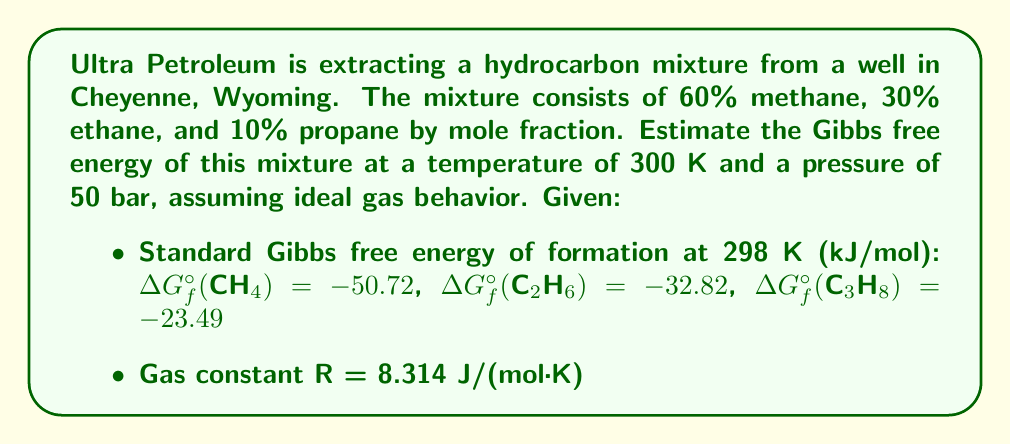Can you answer this question? To estimate the Gibbs free energy of the hydrocarbon mixture, we'll follow these steps:

1) First, calculate the standard Gibbs free energy of the mixture at 298 K:

   $$G_{mix}^{\circ} = \sum_{i} x_i \Delta G_f^{\circ}(i)$$

   where $x_i$ is the mole fraction of each component.

   $$G_{mix}^{\circ} = 0.6(-50.72) + 0.3(-32.82) + 0.1(-23.49) = -42.71 \text{ kJ/mol}$$

2) Adjust for temperature change from 298 K to 300 K. For small temperature changes, we can approximate:

   $$G(T) \approx G^{\circ} - S^{\circ}(T - 298)$$

   However, the change is so small (2 K) that we can neglect this adjustment.

3) Account for pressure change using the ideal gas equation:

   $$G(P) = G^{\circ} + RT \ln(\frac{P}{P^{\circ}})$$

   where $P^{\circ} = 1 \text{ bar}$

   $$G(50 \text{ bar}) = -42.71 \times 10^3 + 8.314 \times 300 \times \ln(50) = -34.71 \text{ kJ/mol}$$

4) Account for mixing entropy:

   $$G_{mixing} = RT \sum_{i} x_i \ln(x_i)$$

   $$G_{mixing} = 8.314 \times 300 \times (0.6\ln(0.6) + 0.3\ln(0.3) + 0.1\ln(0.1)) = -2.20 \text{ kJ/mol}$$

5) The total Gibbs free energy is the sum of these contributions:

   $$G_{total} = G(50 \text{ bar}) + G_{mixing} = -34.71 - 2.20 = -36.91 \text{ kJ/mol}$$
Answer: $-36.91 \text{ kJ/mol}$ 